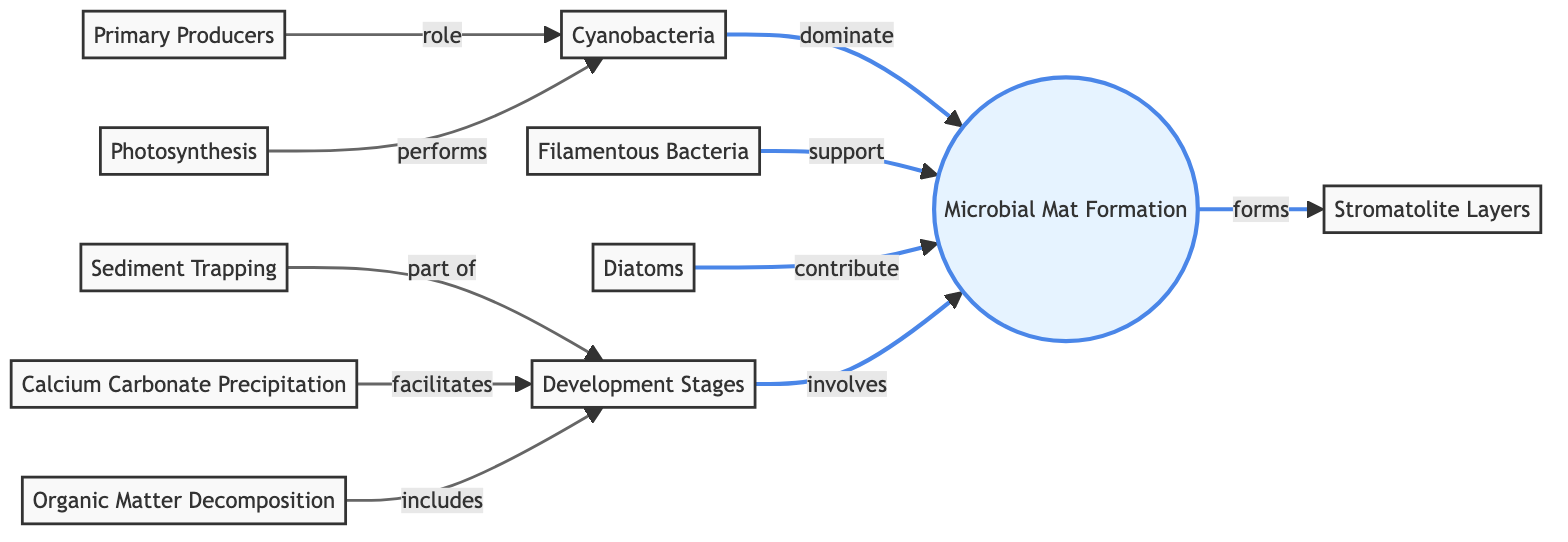What is the primary producer in the microbial mat formation? The primary producer identified in the diagram is "Cyanobacteria," as it directly contributes to the formation of microbial mats and is labeled as a primary producer.
Answer: Cyanobacteria How many types of organisms contribute to microbial mat formation? According to the diagram, there are three types of organisms that contribute: "Cyanobacteria," "Filamentous Bacteria," and "Diatoms."
Answer: Three What role do primary producers play in the formation of microbial mats? The diagram indicates that primary producers like cyanobacteria play the role of performing photosynthesis, which is essential for the microbial mat's formation and function.
Answer: Performing photosynthesis What do sediment trapping and calcium carbonate precipitation have in common in this context? Both processes are part of the development stages in microbial mat formation, facilitating the growth and structure of stromatolites as indicated in the diagram.
Answer: Part of development stages Which organism dominates the microbial mat formation? The diagram specifies that "Cyanobacteria" dominates the microbial mat formation, establishing its primary role.
Answer: Cyanobacteria How does organic matter decomposition relate to development stages in microbial mats? The diagram shows that organic matter decomposition is included in the development stages, indicating its importance in shaping and sustaining microbial mats.
Answer: Included in development stages Which process facilitates the development stages of microbial mats? The diagram lists "Calcium Carbonate Precipitation" as a process that facilitates the development stages, showing its importance for the structure of microbial mats.
Answer: Calcium Carbonate Precipitation What is the relationship between filamentous bacteria and microbial mat formation? The diagram states that filamentous bacteria support the microbial mat formation, indicating their role in maintaining the structure and function of the mats.
Answer: Support How many distinct stages are involved in the microbial mat formation according to the diagram? The diagram illustrates one distinct stage, which is labeled as "Development Stages," encompassing various processes included in microbial mat formation.
Answer: One 